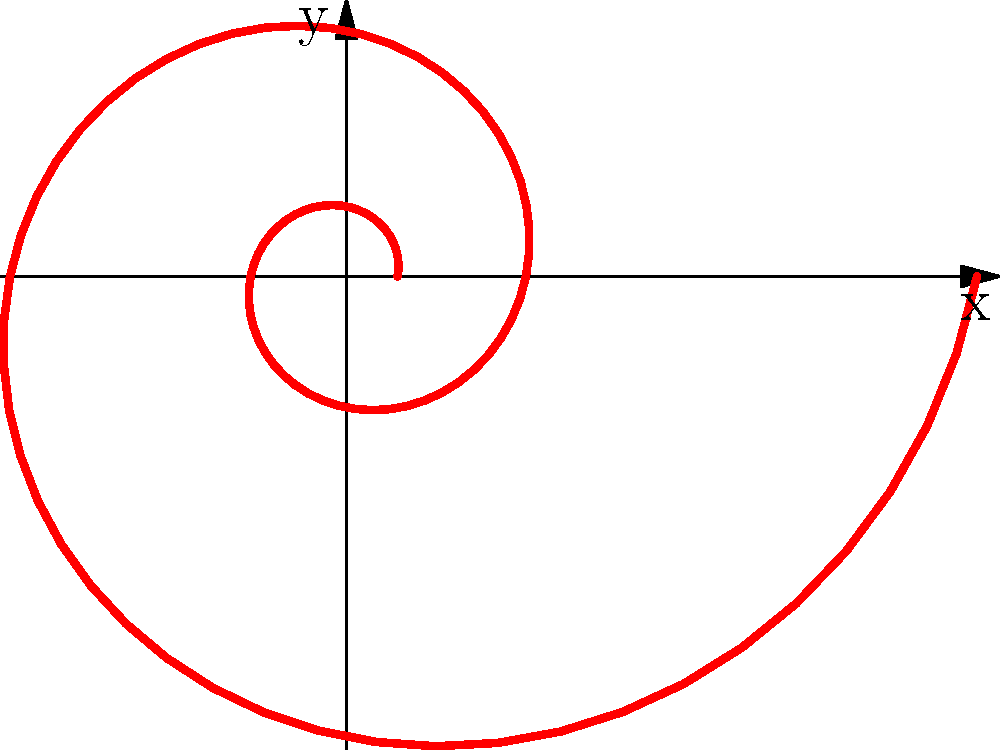In your pursuit of groundbreaking stories, you've stumbled upon a fascinating connection between mathematics and nature. The spiral pattern shown in the graph resembles certain natural phenomena. Which equation best describes this logarithmic spiral, and what natural structure does it most closely resemble?

a) $r = \theta$
b) $r = e^{0.2\theta}$
c) $r = \sin(\theta)$
d) $r = \sqrt{\theta}$ To answer this question, let's analyze the spiral pattern and its connection to natural phenomena:

1. Observe the spiral: The curve starts near the origin and gradually expands outward, forming a logarithmic spiral.

2. Logarithmic spirals are characterized by the equation $r = ae^{b\theta}$, where $a$ and $b$ are constants.

3. Among the given options, only $r = e^{0.2\theta}$ fits this form, with $a = 1$ and $b = 0.2$.

4. This type of spiral is found in various natural structures, but it most closely resembles the spiral pattern of a nautilus shell.

5. Nautilus shells exhibit a logarithmic spiral growth pattern, where each new chamber is proportionally larger than the previous one, maintaining the same shape as the shell grows.

6. Other examples in nature include spiral galaxies, hurricane patterns, and the arrangement of seeds in sunflowers, but the nautilus shell is the most iconic representation of this mathematical pattern.

The logarithmic spiral's prevalence in nature makes it a compelling subject for a groundbreaking story, connecting mathematics, biology, and the underlying patterns of the universe.
Answer: $r = e^{0.2\theta}$; Nautilus shell 